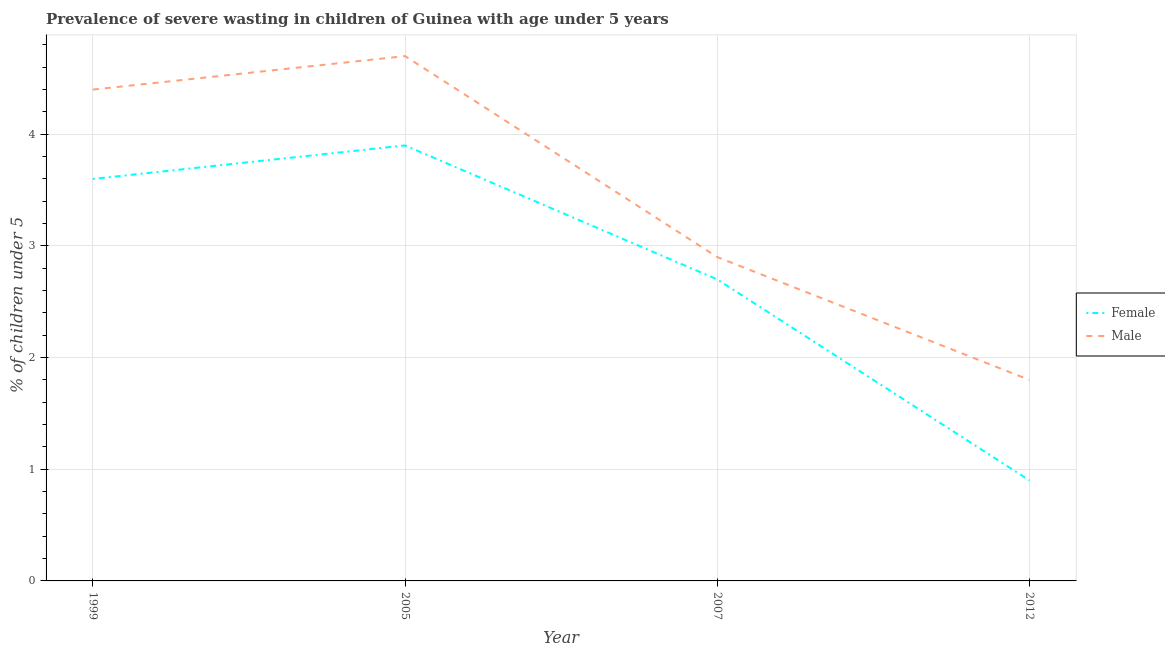Is the number of lines equal to the number of legend labels?
Your response must be concise. Yes. What is the percentage of undernourished male children in 2005?
Your answer should be very brief. 4.7. Across all years, what is the maximum percentage of undernourished male children?
Your answer should be compact. 4.7. Across all years, what is the minimum percentage of undernourished male children?
Make the answer very short. 1.8. In which year was the percentage of undernourished male children minimum?
Provide a succinct answer. 2012. What is the total percentage of undernourished female children in the graph?
Ensure brevity in your answer.  11.1. What is the difference between the percentage of undernourished female children in 1999 and that in 2012?
Offer a terse response. 2.7. What is the difference between the percentage of undernourished female children in 2012 and the percentage of undernourished male children in 1999?
Your response must be concise. -3.5. What is the average percentage of undernourished male children per year?
Give a very brief answer. 3.45. In the year 2007, what is the difference between the percentage of undernourished male children and percentage of undernourished female children?
Give a very brief answer. 0.2. In how many years, is the percentage of undernourished male children greater than 1.8 %?
Offer a very short reply. 3. What is the ratio of the percentage of undernourished female children in 2005 to that in 2012?
Your response must be concise. 4.33. What is the difference between the highest and the second highest percentage of undernourished male children?
Offer a very short reply. 0.3. What is the difference between the highest and the lowest percentage of undernourished female children?
Provide a succinct answer. 3. Is the sum of the percentage of undernourished male children in 2007 and 2012 greater than the maximum percentage of undernourished female children across all years?
Your response must be concise. Yes. Does the percentage of undernourished male children monotonically increase over the years?
Provide a succinct answer. No. Is the percentage of undernourished female children strictly greater than the percentage of undernourished male children over the years?
Ensure brevity in your answer.  No. Is the percentage of undernourished male children strictly less than the percentage of undernourished female children over the years?
Keep it short and to the point. No. How many lines are there?
Offer a very short reply. 2. How many years are there in the graph?
Your response must be concise. 4. What is the difference between two consecutive major ticks on the Y-axis?
Provide a short and direct response. 1. Where does the legend appear in the graph?
Offer a very short reply. Center right. How are the legend labels stacked?
Offer a terse response. Vertical. What is the title of the graph?
Offer a very short reply. Prevalence of severe wasting in children of Guinea with age under 5 years. What is the label or title of the Y-axis?
Provide a succinct answer.  % of children under 5. What is the  % of children under 5 in Female in 1999?
Offer a terse response. 3.6. What is the  % of children under 5 of Male in 1999?
Make the answer very short. 4.4. What is the  % of children under 5 of Female in 2005?
Keep it short and to the point. 3.9. What is the  % of children under 5 of Male in 2005?
Keep it short and to the point. 4.7. What is the  % of children under 5 of Female in 2007?
Your answer should be very brief. 2.7. What is the  % of children under 5 in Male in 2007?
Provide a succinct answer. 2.9. What is the  % of children under 5 in Female in 2012?
Provide a succinct answer. 0.9. What is the  % of children under 5 of Male in 2012?
Offer a terse response. 1.8. Across all years, what is the maximum  % of children under 5 of Female?
Ensure brevity in your answer.  3.9. Across all years, what is the maximum  % of children under 5 in Male?
Keep it short and to the point. 4.7. Across all years, what is the minimum  % of children under 5 of Female?
Ensure brevity in your answer.  0.9. Across all years, what is the minimum  % of children under 5 in Male?
Give a very brief answer. 1.8. What is the total  % of children under 5 in Male in the graph?
Offer a terse response. 13.8. What is the difference between the  % of children under 5 of Male in 1999 and that in 2007?
Your answer should be very brief. 1.5. What is the difference between the  % of children under 5 of Female in 1999 and that in 2012?
Your response must be concise. 2.7. What is the difference between the  % of children under 5 in Female in 2005 and that in 2012?
Offer a very short reply. 3. What is the difference between the  % of children under 5 in Female in 1999 and the  % of children under 5 in Male in 2005?
Your answer should be compact. -1.1. What is the difference between the  % of children under 5 in Female in 2005 and the  % of children under 5 in Male in 2012?
Ensure brevity in your answer.  2.1. What is the difference between the  % of children under 5 in Female in 2007 and the  % of children under 5 in Male in 2012?
Keep it short and to the point. 0.9. What is the average  % of children under 5 of Female per year?
Offer a very short reply. 2.77. What is the average  % of children under 5 in Male per year?
Your answer should be very brief. 3.45. In the year 1999, what is the difference between the  % of children under 5 in Female and  % of children under 5 in Male?
Keep it short and to the point. -0.8. What is the ratio of the  % of children under 5 of Male in 1999 to that in 2005?
Give a very brief answer. 0.94. What is the ratio of the  % of children under 5 in Female in 1999 to that in 2007?
Give a very brief answer. 1.33. What is the ratio of the  % of children under 5 in Male in 1999 to that in 2007?
Make the answer very short. 1.52. What is the ratio of the  % of children under 5 in Female in 1999 to that in 2012?
Ensure brevity in your answer.  4. What is the ratio of the  % of children under 5 in Male in 1999 to that in 2012?
Provide a succinct answer. 2.44. What is the ratio of the  % of children under 5 in Female in 2005 to that in 2007?
Offer a very short reply. 1.44. What is the ratio of the  % of children under 5 of Male in 2005 to that in 2007?
Your answer should be very brief. 1.62. What is the ratio of the  % of children under 5 in Female in 2005 to that in 2012?
Provide a short and direct response. 4.33. What is the ratio of the  % of children under 5 in Male in 2005 to that in 2012?
Your answer should be very brief. 2.61. What is the ratio of the  % of children under 5 of Male in 2007 to that in 2012?
Offer a terse response. 1.61. What is the difference between the highest and the second highest  % of children under 5 in Male?
Keep it short and to the point. 0.3. 